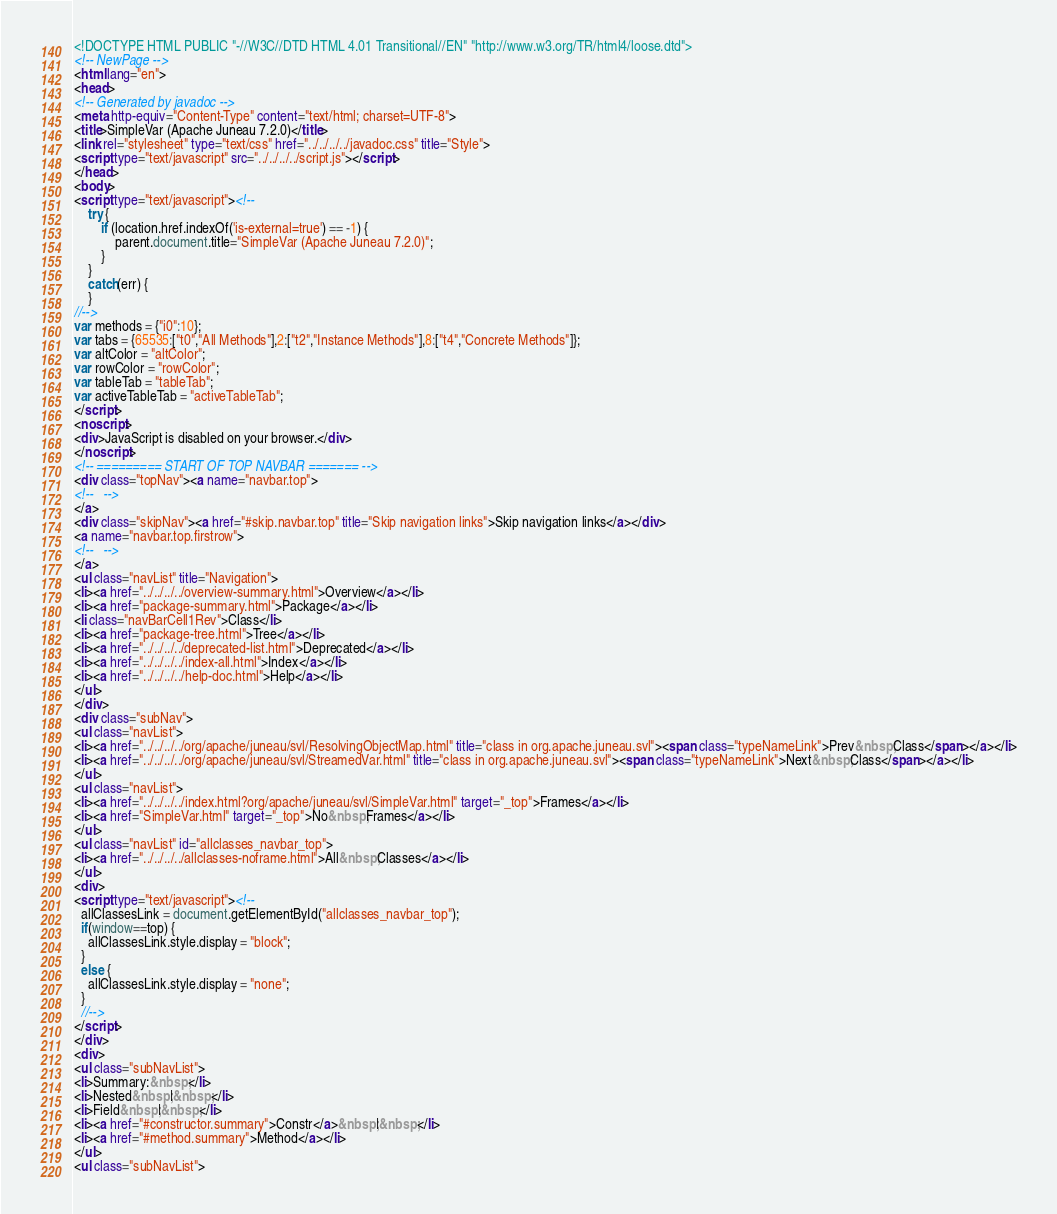Convert code to text. <code><loc_0><loc_0><loc_500><loc_500><_HTML_><!DOCTYPE HTML PUBLIC "-//W3C//DTD HTML 4.01 Transitional//EN" "http://www.w3.org/TR/html4/loose.dtd">
<!-- NewPage -->
<html lang="en">
<head>
<!-- Generated by javadoc -->
<meta http-equiv="Content-Type" content="text/html; charset=UTF-8">
<title>SimpleVar (Apache Juneau 7.2.0)</title>
<link rel="stylesheet" type="text/css" href="../../../../javadoc.css" title="Style">
<script type="text/javascript" src="../../../../script.js"></script>
</head>
<body>
<script type="text/javascript"><!--
    try {
        if (location.href.indexOf('is-external=true') == -1) {
            parent.document.title="SimpleVar (Apache Juneau 7.2.0)";
        }
    }
    catch(err) {
    }
//-->
var methods = {"i0":10};
var tabs = {65535:["t0","All Methods"],2:["t2","Instance Methods"],8:["t4","Concrete Methods"]};
var altColor = "altColor";
var rowColor = "rowColor";
var tableTab = "tableTab";
var activeTableTab = "activeTableTab";
</script>
<noscript>
<div>JavaScript is disabled on your browser.</div>
</noscript>
<!-- ========= START OF TOP NAVBAR ======= -->
<div class="topNav"><a name="navbar.top">
<!--   -->
</a>
<div class="skipNav"><a href="#skip.navbar.top" title="Skip navigation links">Skip navigation links</a></div>
<a name="navbar.top.firstrow">
<!--   -->
</a>
<ul class="navList" title="Navigation">
<li><a href="../../../../overview-summary.html">Overview</a></li>
<li><a href="package-summary.html">Package</a></li>
<li class="navBarCell1Rev">Class</li>
<li><a href="package-tree.html">Tree</a></li>
<li><a href="../../../../deprecated-list.html">Deprecated</a></li>
<li><a href="../../../../index-all.html">Index</a></li>
<li><a href="../../../../help-doc.html">Help</a></li>
</ul>
</div>
<div class="subNav">
<ul class="navList">
<li><a href="../../../../org/apache/juneau/svl/ResolvingObjectMap.html" title="class in org.apache.juneau.svl"><span class="typeNameLink">Prev&nbsp;Class</span></a></li>
<li><a href="../../../../org/apache/juneau/svl/StreamedVar.html" title="class in org.apache.juneau.svl"><span class="typeNameLink">Next&nbsp;Class</span></a></li>
</ul>
<ul class="navList">
<li><a href="../../../../index.html?org/apache/juneau/svl/SimpleVar.html" target="_top">Frames</a></li>
<li><a href="SimpleVar.html" target="_top">No&nbsp;Frames</a></li>
</ul>
<ul class="navList" id="allclasses_navbar_top">
<li><a href="../../../../allclasses-noframe.html">All&nbsp;Classes</a></li>
</ul>
<div>
<script type="text/javascript"><!--
  allClassesLink = document.getElementById("allclasses_navbar_top");
  if(window==top) {
    allClassesLink.style.display = "block";
  }
  else {
    allClassesLink.style.display = "none";
  }
  //-->
</script>
</div>
<div>
<ul class="subNavList">
<li>Summary:&nbsp;</li>
<li>Nested&nbsp;|&nbsp;</li>
<li>Field&nbsp;|&nbsp;</li>
<li><a href="#constructor.summary">Constr</a>&nbsp;|&nbsp;</li>
<li><a href="#method.summary">Method</a></li>
</ul>
<ul class="subNavList"></code> 